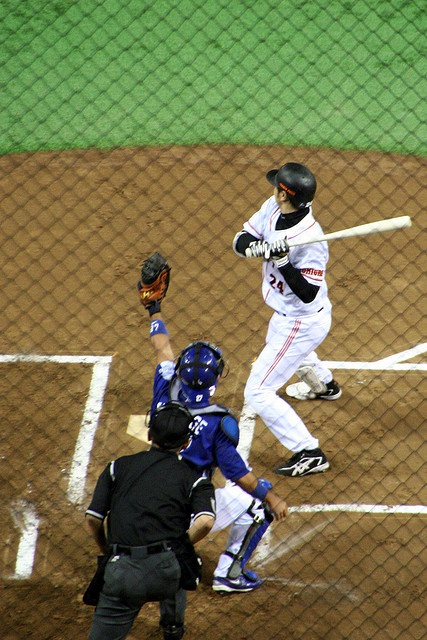Describe the objects in this image and their specific colors. I can see people in green, lavender, black, olive, and darkgray tones, people in green, black, olive, gray, and tan tones, people in green, black, navy, lavender, and gray tones, and baseball glove in green, black, olive, and maroon tones in this image. 